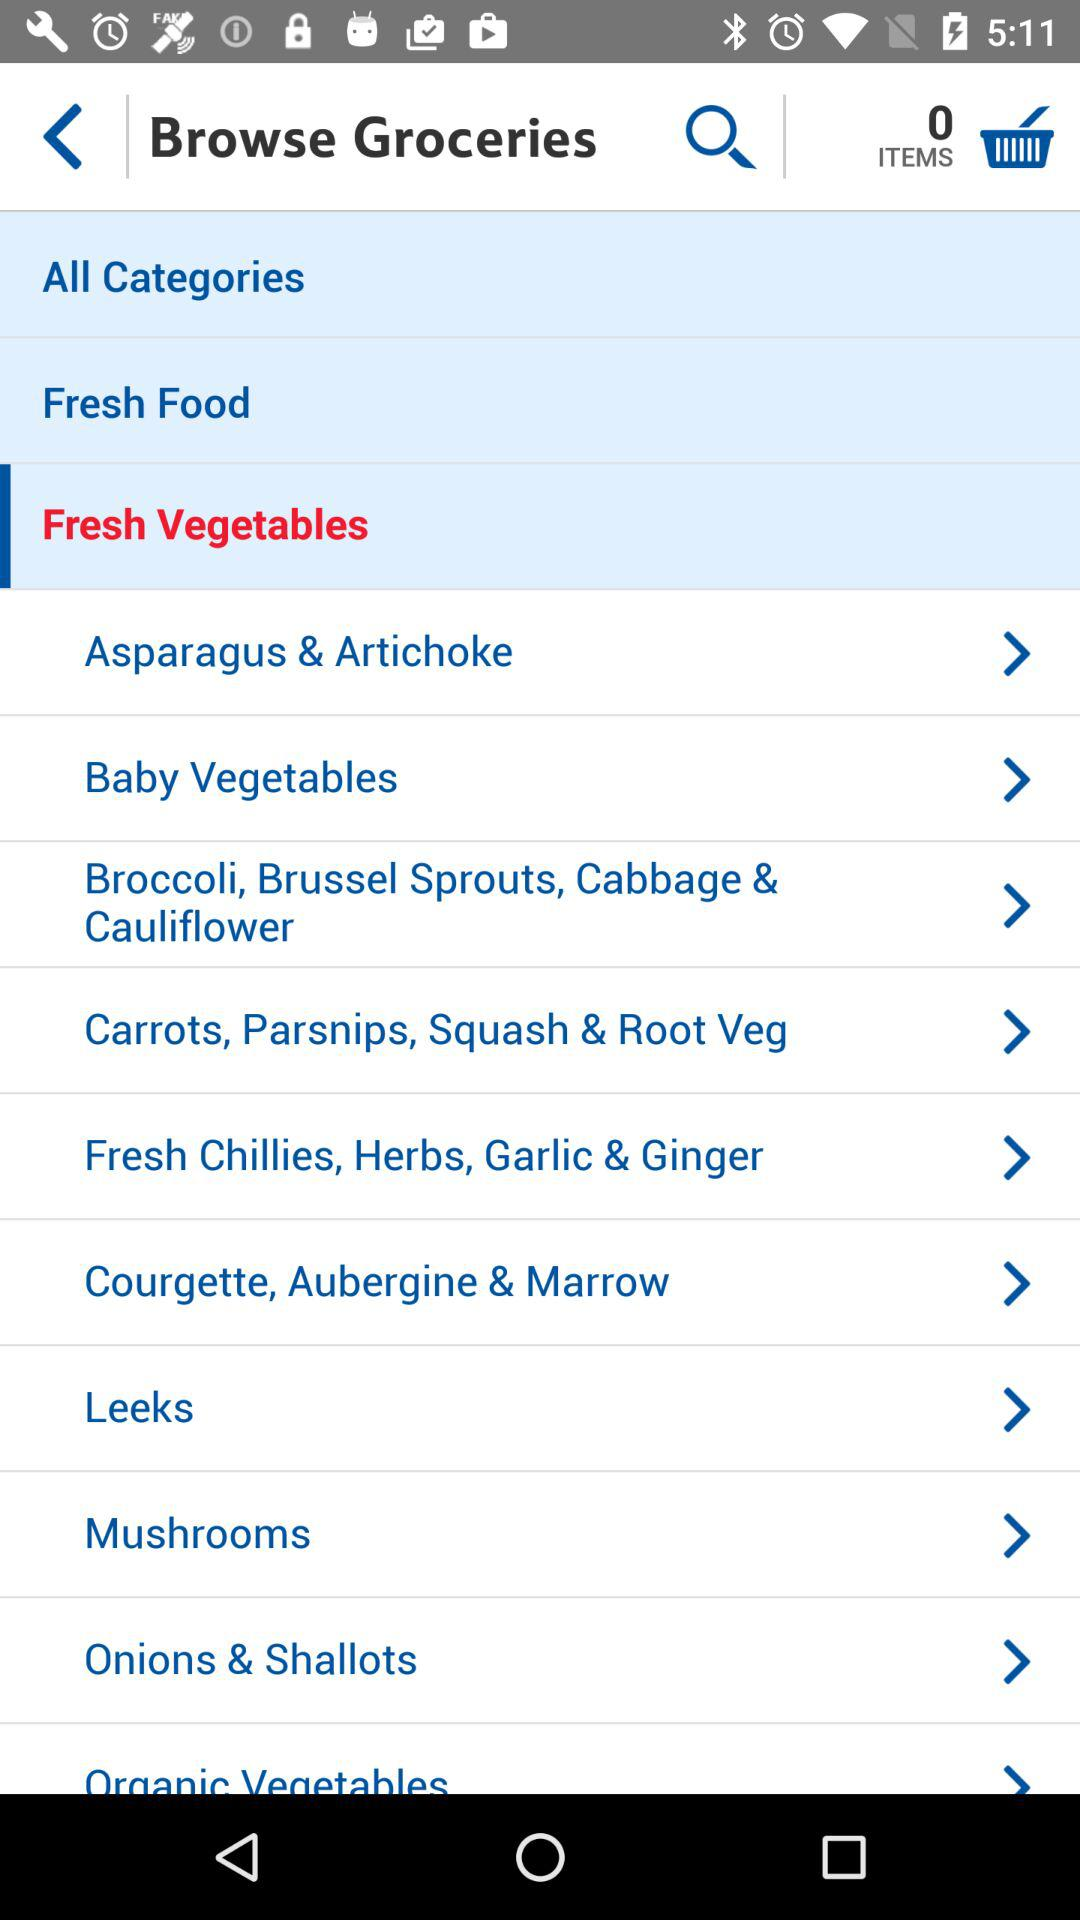How many items are there in the cart? There are 0 items in the cart. 